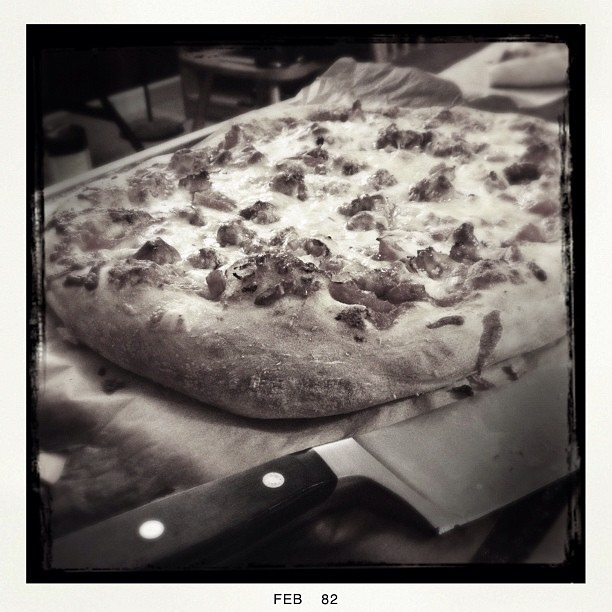Please extract the text content from this image. FEB 82 